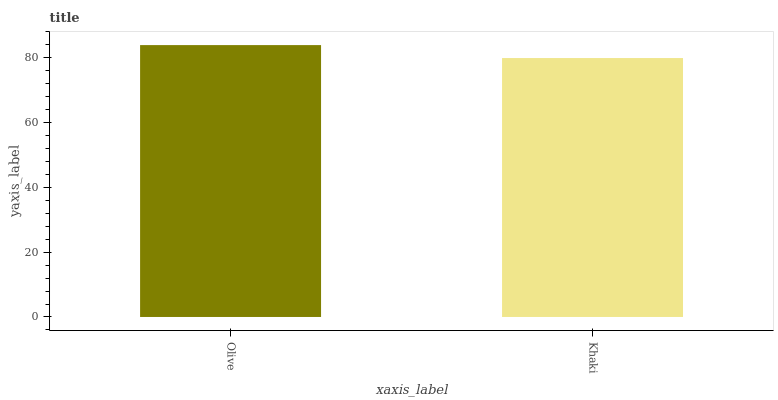Is Khaki the minimum?
Answer yes or no. Yes. Is Olive the maximum?
Answer yes or no. Yes. Is Khaki the maximum?
Answer yes or no. No. Is Olive greater than Khaki?
Answer yes or no. Yes. Is Khaki less than Olive?
Answer yes or no. Yes. Is Khaki greater than Olive?
Answer yes or no. No. Is Olive less than Khaki?
Answer yes or no. No. Is Olive the high median?
Answer yes or no. Yes. Is Khaki the low median?
Answer yes or no. Yes. Is Khaki the high median?
Answer yes or no. No. Is Olive the low median?
Answer yes or no. No. 